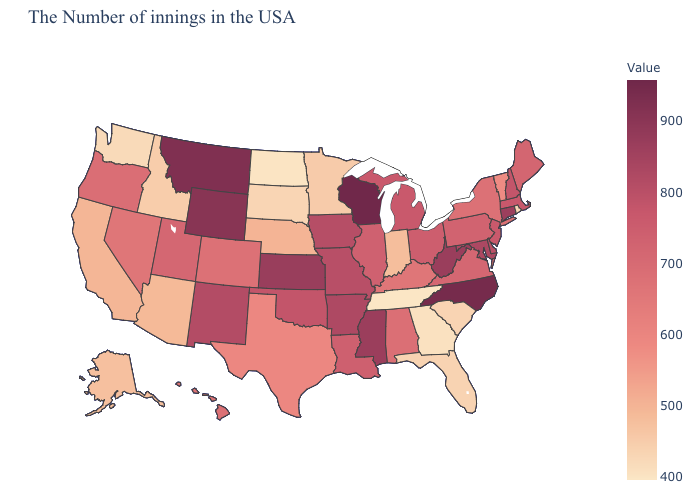Does the map have missing data?
Quick response, please. No. Which states have the highest value in the USA?
Be succinct. Wisconsin. Among the states that border Tennessee , does Georgia have the lowest value?
Quick response, please. Yes. Which states have the lowest value in the USA?
Quick response, please. Tennessee. Does Alabama have a higher value than Michigan?
Quick response, please. No. Which states hav the highest value in the MidWest?
Quick response, please. Wisconsin. Among the states that border North Carolina , which have the highest value?
Keep it brief. Virginia. 